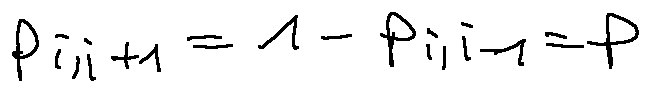Convert formula to latex. <formula><loc_0><loc_0><loc_500><loc_500>p _ { i , i + 1 } = 1 - p _ { i , i - 1 } = p</formula> 